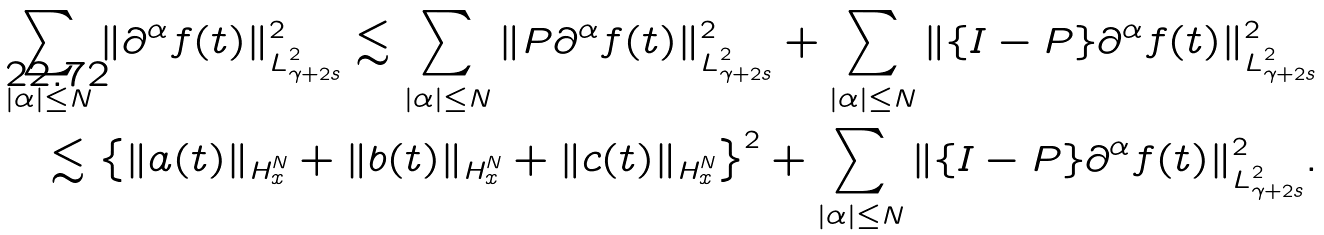Convert formula to latex. <formula><loc_0><loc_0><loc_500><loc_500>\sum _ { | \alpha | \leq N } \| \partial ^ { \alpha } f ( t ) \| _ { L ^ { 2 } _ { \gamma + 2 s } } ^ { 2 } \lesssim \sum _ { | \alpha | \leq N } \| { P } \partial ^ { \alpha } f ( t ) \| _ { L ^ { 2 } _ { \gamma + 2 s } } ^ { 2 } + \sum _ { | \alpha | \leq N } \| \{ { I - P } \} \partial ^ { \alpha } f ( t ) \| _ { L ^ { 2 } _ { \gamma + 2 s } } ^ { 2 } \\ \lesssim \left \{ \| a ( t ) \| _ { H ^ { N } _ { x } } + \| b ( t ) \| _ { H ^ { N } _ { x } } + \| c ( t ) \| _ { H ^ { N } _ { x } } \right \} ^ { 2 } + \sum _ { | \alpha | \leq N } \| \{ { I - P } \} \partial ^ { \alpha } f ( t ) \| _ { L ^ { 2 } _ { \gamma + 2 s } } ^ { 2 } .</formula> 